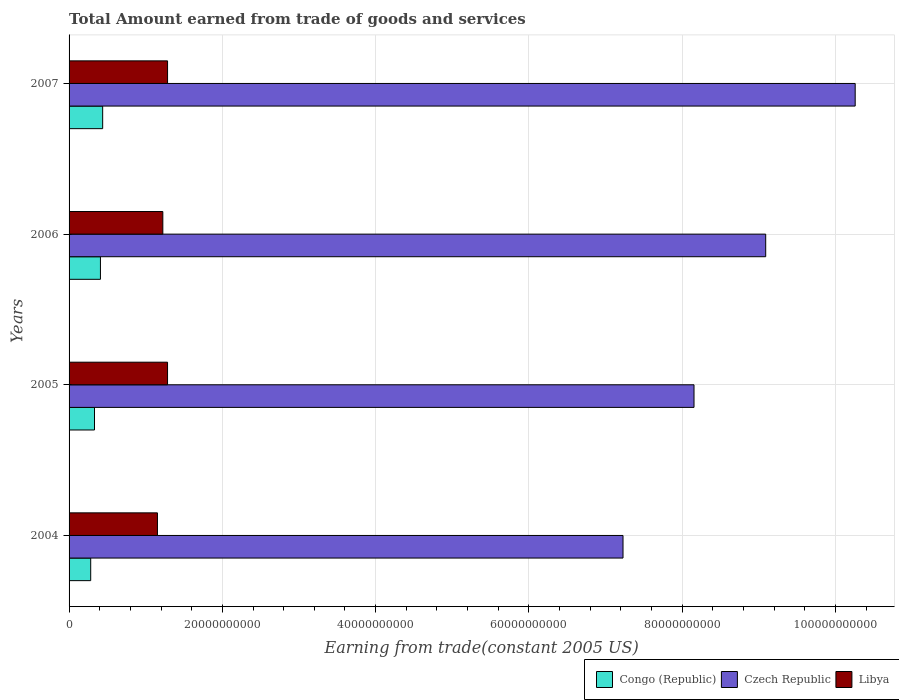How many different coloured bars are there?
Give a very brief answer. 3. Are the number of bars on each tick of the Y-axis equal?
Offer a very short reply. Yes. How many bars are there on the 4th tick from the bottom?
Provide a short and direct response. 3. What is the label of the 2nd group of bars from the top?
Keep it short and to the point. 2006. What is the total amount earned by trading goods and services in Czech Republic in 2005?
Offer a very short reply. 8.15e+1. Across all years, what is the maximum total amount earned by trading goods and services in Czech Republic?
Your response must be concise. 1.03e+11. Across all years, what is the minimum total amount earned by trading goods and services in Czech Republic?
Your answer should be compact. 7.23e+1. In which year was the total amount earned by trading goods and services in Congo (Republic) maximum?
Give a very brief answer. 2007. In which year was the total amount earned by trading goods and services in Czech Republic minimum?
Your answer should be very brief. 2004. What is the total total amount earned by trading goods and services in Czech Republic in the graph?
Offer a very short reply. 3.47e+11. What is the difference between the total amount earned by trading goods and services in Congo (Republic) in 2004 and that in 2006?
Offer a terse response. -1.27e+09. What is the difference between the total amount earned by trading goods and services in Libya in 2004 and the total amount earned by trading goods and services in Congo (Republic) in 2005?
Offer a very short reply. 8.21e+09. What is the average total amount earned by trading goods and services in Libya per year?
Your answer should be very brief. 1.24e+1. In the year 2005, what is the difference between the total amount earned by trading goods and services in Libya and total amount earned by trading goods and services in Czech Republic?
Keep it short and to the point. -6.87e+1. What is the ratio of the total amount earned by trading goods and services in Congo (Republic) in 2005 to that in 2007?
Provide a succinct answer. 0.76. What is the difference between the highest and the second highest total amount earned by trading goods and services in Czech Republic?
Provide a succinct answer. 1.17e+1. What is the difference between the highest and the lowest total amount earned by trading goods and services in Congo (Republic)?
Provide a short and direct response. 1.56e+09. In how many years, is the total amount earned by trading goods and services in Libya greater than the average total amount earned by trading goods and services in Libya taken over all years?
Give a very brief answer. 2. Is the sum of the total amount earned by trading goods and services in Libya in 2004 and 2005 greater than the maximum total amount earned by trading goods and services in Czech Republic across all years?
Provide a short and direct response. No. What does the 1st bar from the top in 2004 represents?
Your answer should be compact. Libya. What does the 3rd bar from the bottom in 2004 represents?
Make the answer very short. Libya. Is it the case that in every year, the sum of the total amount earned by trading goods and services in Libya and total amount earned by trading goods and services in Congo (Republic) is greater than the total amount earned by trading goods and services in Czech Republic?
Your answer should be compact. No. How many years are there in the graph?
Provide a short and direct response. 4. Are the values on the major ticks of X-axis written in scientific E-notation?
Provide a short and direct response. No. Where does the legend appear in the graph?
Your answer should be compact. Bottom right. What is the title of the graph?
Your answer should be compact. Total Amount earned from trade of goods and services. Does "Saudi Arabia" appear as one of the legend labels in the graph?
Your answer should be compact. No. What is the label or title of the X-axis?
Provide a succinct answer. Earning from trade(constant 2005 US). What is the label or title of the Y-axis?
Offer a terse response. Years. What is the Earning from trade(constant 2005 US) of Congo (Republic) in 2004?
Your answer should be very brief. 2.82e+09. What is the Earning from trade(constant 2005 US) of Czech Republic in 2004?
Keep it short and to the point. 7.23e+1. What is the Earning from trade(constant 2005 US) in Libya in 2004?
Give a very brief answer. 1.15e+1. What is the Earning from trade(constant 2005 US) in Congo (Republic) in 2005?
Offer a terse response. 3.32e+09. What is the Earning from trade(constant 2005 US) of Czech Republic in 2005?
Your answer should be compact. 8.15e+1. What is the Earning from trade(constant 2005 US) of Libya in 2005?
Your response must be concise. 1.28e+1. What is the Earning from trade(constant 2005 US) in Congo (Republic) in 2006?
Your answer should be compact. 4.09e+09. What is the Earning from trade(constant 2005 US) in Czech Republic in 2006?
Ensure brevity in your answer.  9.09e+1. What is the Earning from trade(constant 2005 US) in Libya in 2006?
Your answer should be compact. 1.22e+1. What is the Earning from trade(constant 2005 US) of Congo (Republic) in 2007?
Ensure brevity in your answer.  4.39e+09. What is the Earning from trade(constant 2005 US) in Czech Republic in 2007?
Keep it short and to the point. 1.03e+11. What is the Earning from trade(constant 2005 US) in Libya in 2007?
Provide a short and direct response. 1.29e+1. Across all years, what is the maximum Earning from trade(constant 2005 US) in Congo (Republic)?
Your response must be concise. 4.39e+09. Across all years, what is the maximum Earning from trade(constant 2005 US) in Czech Republic?
Make the answer very short. 1.03e+11. Across all years, what is the maximum Earning from trade(constant 2005 US) of Libya?
Your response must be concise. 1.29e+1. Across all years, what is the minimum Earning from trade(constant 2005 US) of Congo (Republic)?
Your answer should be compact. 2.82e+09. Across all years, what is the minimum Earning from trade(constant 2005 US) in Czech Republic?
Give a very brief answer. 7.23e+1. Across all years, what is the minimum Earning from trade(constant 2005 US) of Libya?
Give a very brief answer. 1.15e+1. What is the total Earning from trade(constant 2005 US) of Congo (Republic) in the graph?
Ensure brevity in your answer.  1.46e+1. What is the total Earning from trade(constant 2005 US) of Czech Republic in the graph?
Make the answer very short. 3.47e+11. What is the total Earning from trade(constant 2005 US) in Libya in the graph?
Offer a very short reply. 4.95e+1. What is the difference between the Earning from trade(constant 2005 US) of Congo (Republic) in 2004 and that in 2005?
Your response must be concise. -4.96e+08. What is the difference between the Earning from trade(constant 2005 US) in Czech Republic in 2004 and that in 2005?
Your response must be concise. -9.26e+09. What is the difference between the Earning from trade(constant 2005 US) of Libya in 2004 and that in 2005?
Keep it short and to the point. -1.32e+09. What is the difference between the Earning from trade(constant 2005 US) in Congo (Republic) in 2004 and that in 2006?
Offer a terse response. -1.27e+09. What is the difference between the Earning from trade(constant 2005 US) of Czech Republic in 2004 and that in 2006?
Your answer should be compact. -1.86e+1. What is the difference between the Earning from trade(constant 2005 US) of Libya in 2004 and that in 2006?
Offer a very short reply. -7.01e+08. What is the difference between the Earning from trade(constant 2005 US) of Congo (Republic) in 2004 and that in 2007?
Your answer should be very brief. -1.56e+09. What is the difference between the Earning from trade(constant 2005 US) in Czech Republic in 2004 and that in 2007?
Ensure brevity in your answer.  -3.03e+1. What is the difference between the Earning from trade(constant 2005 US) of Libya in 2004 and that in 2007?
Offer a very short reply. -1.32e+09. What is the difference between the Earning from trade(constant 2005 US) in Congo (Republic) in 2005 and that in 2006?
Provide a succinct answer. -7.75e+08. What is the difference between the Earning from trade(constant 2005 US) of Czech Republic in 2005 and that in 2006?
Make the answer very short. -9.35e+09. What is the difference between the Earning from trade(constant 2005 US) in Libya in 2005 and that in 2006?
Offer a terse response. 6.16e+08. What is the difference between the Earning from trade(constant 2005 US) of Congo (Republic) in 2005 and that in 2007?
Make the answer very short. -1.07e+09. What is the difference between the Earning from trade(constant 2005 US) in Czech Republic in 2005 and that in 2007?
Provide a succinct answer. -2.10e+1. What is the difference between the Earning from trade(constant 2005 US) of Libya in 2005 and that in 2007?
Your answer should be very brief. -3.40e+06. What is the difference between the Earning from trade(constant 2005 US) of Congo (Republic) in 2006 and that in 2007?
Keep it short and to the point. -2.92e+08. What is the difference between the Earning from trade(constant 2005 US) of Czech Republic in 2006 and that in 2007?
Offer a terse response. -1.17e+1. What is the difference between the Earning from trade(constant 2005 US) in Libya in 2006 and that in 2007?
Offer a terse response. -6.19e+08. What is the difference between the Earning from trade(constant 2005 US) in Congo (Republic) in 2004 and the Earning from trade(constant 2005 US) in Czech Republic in 2005?
Your answer should be very brief. -7.87e+1. What is the difference between the Earning from trade(constant 2005 US) of Congo (Republic) in 2004 and the Earning from trade(constant 2005 US) of Libya in 2005?
Offer a terse response. -1.00e+1. What is the difference between the Earning from trade(constant 2005 US) of Czech Republic in 2004 and the Earning from trade(constant 2005 US) of Libya in 2005?
Give a very brief answer. 5.94e+1. What is the difference between the Earning from trade(constant 2005 US) of Congo (Republic) in 2004 and the Earning from trade(constant 2005 US) of Czech Republic in 2006?
Your answer should be very brief. -8.81e+1. What is the difference between the Earning from trade(constant 2005 US) of Congo (Republic) in 2004 and the Earning from trade(constant 2005 US) of Libya in 2006?
Provide a short and direct response. -9.41e+09. What is the difference between the Earning from trade(constant 2005 US) of Czech Republic in 2004 and the Earning from trade(constant 2005 US) of Libya in 2006?
Give a very brief answer. 6.00e+1. What is the difference between the Earning from trade(constant 2005 US) of Congo (Republic) in 2004 and the Earning from trade(constant 2005 US) of Czech Republic in 2007?
Offer a terse response. -9.97e+1. What is the difference between the Earning from trade(constant 2005 US) in Congo (Republic) in 2004 and the Earning from trade(constant 2005 US) in Libya in 2007?
Your response must be concise. -1.00e+1. What is the difference between the Earning from trade(constant 2005 US) in Czech Republic in 2004 and the Earning from trade(constant 2005 US) in Libya in 2007?
Your answer should be very brief. 5.94e+1. What is the difference between the Earning from trade(constant 2005 US) in Congo (Republic) in 2005 and the Earning from trade(constant 2005 US) in Czech Republic in 2006?
Provide a succinct answer. -8.76e+1. What is the difference between the Earning from trade(constant 2005 US) of Congo (Republic) in 2005 and the Earning from trade(constant 2005 US) of Libya in 2006?
Your answer should be very brief. -8.91e+09. What is the difference between the Earning from trade(constant 2005 US) of Czech Republic in 2005 and the Earning from trade(constant 2005 US) of Libya in 2006?
Keep it short and to the point. 6.93e+1. What is the difference between the Earning from trade(constant 2005 US) in Congo (Republic) in 2005 and the Earning from trade(constant 2005 US) in Czech Republic in 2007?
Offer a terse response. -9.93e+1. What is the difference between the Earning from trade(constant 2005 US) in Congo (Republic) in 2005 and the Earning from trade(constant 2005 US) in Libya in 2007?
Ensure brevity in your answer.  -9.53e+09. What is the difference between the Earning from trade(constant 2005 US) of Czech Republic in 2005 and the Earning from trade(constant 2005 US) of Libya in 2007?
Make the answer very short. 6.87e+1. What is the difference between the Earning from trade(constant 2005 US) in Congo (Republic) in 2006 and the Earning from trade(constant 2005 US) in Czech Republic in 2007?
Provide a short and direct response. -9.85e+1. What is the difference between the Earning from trade(constant 2005 US) of Congo (Republic) in 2006 and the Earning from trade(constant 2005 US) of Libya in 2007?
Your answer should be very brief. -8.76e+09. What is the difference between the Earning from trade(constant 2005 US) in Czech Republic in 2006 and the Earning from trade(constant 2005 US) in Libya in 2007?
Provide a succinct answer. 7.80e+1. What is the average Earning from trade(constant 2005 US) in Congo (Republic) per year?
Provide a short and direct response. 3.65e+09. What is the average Earning from trade(constant 2005 US) of Czech Republic per year?
Offer a terse response. 8.68e+1. What is the average Earning from trade(constant 2005 US) in Libya per year?
Make the answer very short. 1.24e+1. In the year 2004, what is the difference between the Earning from trade(constant 2005 US) of Congo (Republic) and Earning from trade(constant 2005 US) of Czech Republic?
Make the answer very short. -6.95e+1. In the year 2004, what is the difference between the Earning from trade(constant 2005 US) in Congo (Republic) and Earning from trade(constant 2005 US) in Libya?
Provide a short and direct response. -8.71e+09. In the year 2004, what is the difference between the Earning from trade(constant 2005 US) of Czech Republic and Earning from trade(constant 2005 US) of Libya?
Keep it short and to the point. 6.07e+1. In the year 2005, what is the difference between the Earning from trade(constant 2005 US) of Congo (Republic) and Earning from trade(constant 2005 US) of Czech Republic?
Your answer should be very brief. -7.82e+1. In the year 2005, what is the difference between the Earning from trade(constant 2005 US) in Congo (Republic) and Earning from trade(constant 2005 US) in Libya?
Offer a terse response. -9.53e+09. In the year 2005, what is the difference between the Earning from trade(constant 2005 US) of Czech Republic and Earning from trade(constant 2005 US) of Libya?
Give a very brief answer. 6.87e+1. In the year 2006, what is the difference between the Earning from trade(constant 2005 US) of Congo (Republic) and Earning from trade(constant 2005 US) of Czech Republic?
Give a very brief answer. -8.68e+1. In the year 2006, what is the difference between the Earning from trade(constant 2005 US) in Congo (Republic) and Earning from trade(constant 2005 US) in Libya?
Provide a succinct answer. -8.14e+09. In the year 2006, what is the difference between the Earning from trade(constant 2005 US) of Czech Republic and Earning from trade(constant 2005 US) of Libya?
Make the answer very short. 7.87e+1. In the year 2007, what is the difference between the Earning from trade(constant 2005 US) in Congo (Republic) and Earning from trade(constant 2005 US) in Czech Republic?
Offer a terse response. -9.82e+1. In the year 2007, what is the difference between the Earning from trade(constant 2005 US) of Congo (Republic) and Earning from trade(constant 2005 US) of Libya?
Ensure brevity in your answer.  -8.47e+09. In the year 2007, what is the difference between the Earning from trade(constant 2005 US) of Czech Republic and Earning from trade(constant 2005 US) of Libya?
Your response must be concise. 8.97e+1. What is the ratio of the Earning from trade(constant 2005 US) in Congo (Republic) in 2004 to that in 2005?
Keep it short and to the point. 0.85. What is the ratio of the Earning from trade(constant 2005 US) of Czech Republic in 2004 to that in 2005?
Your answer should be compact. 0.89. What is the ratio of the Earning from trade(constant 2005 US) of Libya in 2004 to that in 2005?
Offer a terse response. 0.9. What is the ratio of the Earning from trade(constant 2005 US) of Congo (Republic) in 2004 to that in 2006?
Your answer should be compact. 0.69. What is the ratio of the Earning from trade(constant 2005 US) in Czech Republic in 2004 to that in 2006?
Your response must be concise. 0.8. What is the ratio of the Earning from trade(constant 2005 US) in Libya in 2004 to that in 2006?
Offer a terse response. 0.94. What is the ratio of the Earning from trade(constant 2005 US) of Congo (Republic) in 2004 to that in 2007?
Ensure brevity in your answer.  0.64. What is the ratio of the Earning from trade(constant 2005 US) in Czech Republic in 2004 to that in 2007?
Provide a succinct answer. 0.7. What is the ratio of the Earning from trade(constant 2005 US) of Libya in 2004 to that in 2007?
Your answer should be compact. 0.9. What is the ratio of the Earning from trade(constant 2005 US) in Congo (Republic) in 2005 to that in 2006?
Offer a very short reply. 0.81. What is the ratio of the Earning from trade(constant 2005 US) of Czech Republic in 2005 to that in 2006?
Keep it short and to the point. 0.9. What is the ratio of the Earning from trade(constant 2005 US) in Libya in 2005 to that in 2006?
Provide a short and direct response. 1.05. What is the ratio of the Earning from trade(constant 2005 US) in Congo (Republic) in 2005 to that in 2007?
Make the answer very short. 0.76. What is the ratio of the Earning from trade(constant 2005 US) in Czech Republic in 2005 to that in 2007?
Your answer should be compact. 0.8. What is the ratio of the Earning from trade(constant 2005 US) in Congo (Republic) in 2006 to that in 2007?
Your answer should be very brief. 0.93. What is the ratio of the Earning from trade(constant 2005 US) in Czech Republic in 2006 to that in 2007?
Your answer should be very brief. 0.89. What is the ratio of the Earning from trade(constant 2005 US) in Libya in 2006 to that in 2007?
Give a very brief answer. 0.95. What is the difference between the highest and the second highest Earning from trade(constant 2005 US) in Congo (Republic)?
Give a very brief answer. 2.92e+08. What is the difference between the highest and the second highest Earning from trade(constant 2005 US) in Czech Republic?
Your response must be concise. 1.17e+1. What is the difference between the highest and the second highest Earning from trade(constant 2005 US) of Libya?
Offer a terse response. 3.40e+06. What is the difference between the highest and the lowest Earning from trade(constant 2005 US) in Congo (Republic)?
Ensure brevity in your answer.  1.56e+09. What is the difference between the highest and the lowest Earning from trade(constant 2005 US) in Czech Republic?
Your answer should be compact. 3.03e+1. What is the difference between the highest and the lowest Earning from trade(constant 2005 US) of Libya?
Your response must be concise. 1.32e+09. 